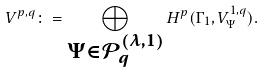Convert formula to latex. <formula><loc_0><loc_0><loc_500><loc_500>V ^ { p , q } \colon = \bigoplus _ { \substack { \Psi \in \mathcal { P } _ { q } ^ { ( \lambda , 1 ) } } } H ^ { p } ( \Gamma _ { 1 } , V ^ { 1 , q } _ { \Psi } ) .</formula> 